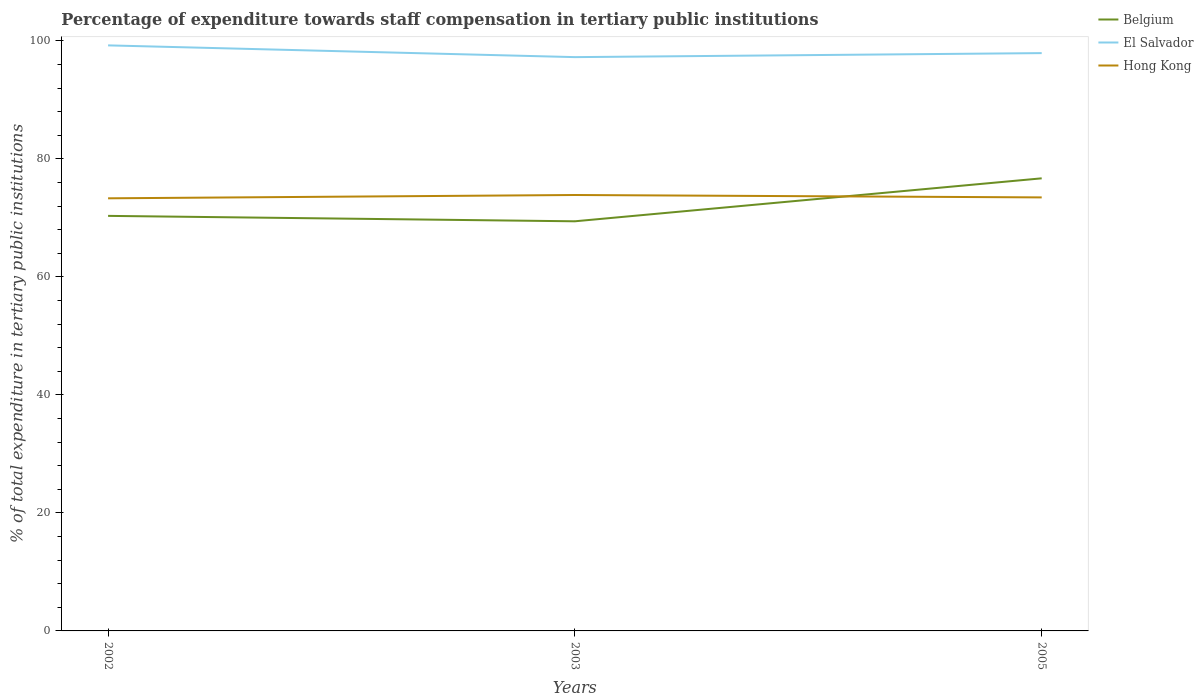Does the line corresponding to El Salvador intersect with the line corresponding to Belgium?
Offer a terse response. No. Is the number of lines equal to the number of legend labels?
Make the answer very short. Yes. Across all years, what is the maximum percentage of expenditure towards staff compensation in Hong Kong?
Offer a terse response. 73.32. What is the total percentage of expenditure towards staff compensation in Hong Kong in the graph?
Offer a very short reply. 0.41. What is the difference between the highest and the second highest percentage of expenditure towards staff compensation in Belgium?
Offer a terse response. 7.28. Is the percentage of expenditure towards staff compensation in Hong Kong strictly greater than the percentage of expenditure towards staff compensation in El Salvador over the years?
Provide a succinct answer. Yes. How many lines are there?
Ensure brevity in your answer.  3. How many years are there in the graph?
Offer a very short reply. 3. What is the difference between two consecutive major ticks on the Y-axis?
Provide a succinct answer. 20. Are the values on the major ticks of Y-axis written in scientific E-notation?
Offer a terse response. No. Where does the legend appear in the graph?
Your answer should be compact. Top right. How are the legend labels stacked?
Offer a terse response. Vertical. What is the title of the graph?
Give a very brief answer. Percentage of expenditure towards staff compensation in tertiary public institutions. Does "Paraguay" appear as one of the legend labels in the graph?
Offer a very short reply. No. What is the label or title of the Y-axis?
Provide a succinct answer. % of total expenditure in tertiary public institutions. What is the % of total expenditure in tertiary public institutions in Belgium in 2002?
Provide a succinct answer. 70.34. What is the % of total expenditure in tertiary public institutions in El Salvador in 2002?
Ensure brevity in your answer.  99.24. What is the % of total expenditure in tertiary public institutions of Hong Kong in 2002?
Offer a terse response. 73.32. What is the % of total expenditure in tertiary public institutions in Belgium in 2003?
Make the answer very short. 69.43. What is the % of total expenditure in tertiary public institutions in El Salvador in 2003?
Give a very brief answer. 97.25. What is the % of total expenditure in tertiary public institutions in Hong Kong in 2003?
Your response must be concise. 73.88. What is the % of total expenditure in tertiary public institutions of Belgium in 2005?
Make the answer very short. 76.71. What is the % of total expenditure in tertiary public institutions in El Salvador in 2005?
Ensure brevity in your answer.  97.93. What is the % of total expenditure in tertiary public institutions of Hong Kong in 2005?
Your answer should be very brief. 73.47. Across all years, what is the maximum % of total expenditure in tertiary public institutions of Belgium?
Your answer should be compact. 76.71. Across all years, what is the maximum % of total expenditure in tertiary public institutions in El Salvador?
Your answer should be compact. 99.24. Across all years, what is the maximum % of total expenditure in tertiary public institutions of Hong Kong?
Keep it short and to the point. 73.88. Across all years, what is the minimum % of total expenditure in tertiary public institutions in Belgium?
Your answer should be very brief. 69.43. Across all years, what is the minimum % of total expenditure in tertiary public institutions of El Salvador?
Offer a very short reply. 97.25. Across all years, what is the minimum % of total expenditure in tertiary public institutions in Hong Kong?
Give a very brief answer. 73.32. What is the total % of total expenditure in tertiary public institutions in Belgium in the graph?
Provide a succinct answer. 216.47. What is the total % of total expenditure in tertiary public institutions in El Salvador in the graph?
Offer a terse response. 294.42. What is the total % of total expenditure in tertiary public institutions in Hong Kong in the graph?
Offer a terse response. 220.67. What is the difference between the % of total expenditure in tertiary public institutions in Belgium in 2002 and that in 2003?
Your response must be concise. 0.92. What is the difference between the % of total expenditure in tertiary public institutions in El Salvador in 2002 and that in 2003?
Your answer should be compact. 1.99. What is the difference between the % of total expenditure in tertiary public institutions in Hong Kong in 2002 and that in 2003?
Offer a terse response. -0.56. What is the difference between the % of total expenditure in tertiary public institutions of Belgium in 2002 and that in 2005?
Offer a very short reply. -6.36. What is the difference between the % of total expenditure in tertiary public institutions of El Salvador in 2002 and that in 2005?
Your response must be concise. 1.31. What is the difference between the % of total expenditure in tertiary public institutions of Hong Kong in 2002 and that in 2005?
Ensure brevity in your answer.  -0.15. What is the difference between the % of total expenditure in tertiary public institutions of Belgium in 2003 and that in 2005?
Your answer should be compact. -7.28. What is the difference between the % of total expenditure in tertiary public institutions in El Salvador in 2003 and that in 2005?
Your answer should be compact. -0.68. What is the difference between the % of total expenditure in tertiary public institutions of Hong Kong in 2003 and that in 2005?
Your answer should be very brief. 0.41. What is the difference between the % of total expenditure in tertiary public institutions in Belgium in 2002 and the % of total expenditure in tertiary public institutions in El Salvador in 2003?
Offer a very short reply. -26.9. What is the difference between the % of total expenditure in tertiary public institutions of Belgium in 2002 and the % of total expenditure in tertiary public institutions of Hong Kong in 2003?
Your answer should be very brief. -3.54. What is the difference between the % of total expenditure in tertiary public institutions of El Salvador in 2002 and the % of total expenditure in tertiary public institutions of Hong Kong in 2003?
Your answer should be compact. 25.36. What is the difference between the % of total expenditure in tertiary public institutions in Belgium in 2002 and the % of total expenditure in tertiary public institutions in El Salvador in 2005?
Your answer should be compact. -27.59. What is the difference between the % of total expenditure in tertiary public institutions of Belgium in 2002 and the % of total expenditure in tertiary public institutions of Hong Kong in 2005?
Ensure brevity in your answer.  -3.13. What is the difference between the % of total expenditure in tertiary public institutions of El Salvador in 2002 and the % of total expenditure in tertiary public institutions of Hong Kong in 2005?
Give a very brief answer. 25.77. What is the difference between the % of total expenditure in tertiary public institutions of Belgium in 2003 and the % of total expenditure in tertiary public institutions of El Salvador in 2005?
Your answer should be very brief. -28.5. What is the difference between the % of total expenditure in tertiary public institutions of Belgium in 2003 and the % of total expenditure in tertiary public institutions of Hong Kong in 2005?
Provide a succinct answer. -4.05. What is the difference between the % of total expenditure in tertiary public institutions of El Salvador in 2003 and the % of total expenditure in tertiary public institutions of Hong Kong in 2005?
Ensure brevity in your answer.  23.78. What is the average % of total expenditure in tertiary public institutions in Belgium per year?
Provide a succinct answer. 72.16. What is the average % of total expenditure in tertiary public institutions in El Salvador per year?
Your answer should be very brief. 98.14. What is the average % of total expenditure in tertiary public institutions in Hong Kong per year?
Give a very brief answer. 73.56. In the year 2002, what is the difference between the % of total expenditure in tertiary public institutions in Belgium and % of total expenditure in tertiary public institutions in El Salvador?
Keep it short and to the point. -28.9. In the year 2002, what is the difference between the % of total expenditure in tertiary public institutions of Belgium and % of total expenditure in tertiary public institutions of Hong Kong?
Make the answer very short. -2.98. In the year 2002, what is the difference between the % of total expenditure in tertiary public institutions in El Salvador and % of total expenditure in tertiary public institutions in Hong Kong?
Offer a terse response. 25.92. In the year 2003, what is the difference between the % of total expenditure in tertiary public institutions in Belgium and % of total expenditure in tertiary public institutions in El Salvador?
Your answer should be very brief. -27.82. In the year 2003, what is the difference between the % of total expenditure in tertiary public institutions of Belgium and % of total expenditure in tertiary public institutions of Hong Kong?
Your answer should be very brief. -4.46. In the year 2003, what is the difference between the % of total expenditure in tertiary public institutions in El Salvador and % of total expenditure in tertiary public institutions in Hong Kong?
Your answer should be compact. 23.37. In the year 2005, what is the difference between the % of total expenditure in tertiary public institutions of Belgium and % of total expenditure in tertiary public institutions of El Salvador?
Your response must be concise. -21.22. In the year 2005, what is the difference between the % of total expenditure in tertiary public institutions of Belgium and % of total expenditure in tertiary public institutions of Hong Kong?
Keep it short and to the point. 3.23. In the year 2005, what is the difference between the % of total expenditure in tertiary public institutions in El Salvador and % of total expenditure in tertiary public institutions in Hong Kong?
Provide a succinct answer. 24.46. What is the ratio of the % of total expenditure in tertiary public institutions of Belgium in 2002 to that in 2003?
Your answer should be very brief. 1.01. What is the ratio of the % of total expenditure in tertiary public institutions of El Salvador in 2002 to that in 2003?
Your answer should be very brief. 1.02. What is the ratio of the % of total expenditure in tertiary public institutions of Hong Kong in 2002 to that in 2003?
Provide a short and direct response. 0.99. What is the ratio of the % of total expenditure in tertiary public institutions in Belgium in 2002 to that in 2005?
Give a very brief answer. 0.92. What is the ratio of the % of total expenditure in tertiary public institutions in El Salvador in 2002 to that in 2005?
Keep it short and to the point. 1.01. What is the ratio of the % of total expenditure in tertiary public institutions of Belgium in 2003 to that in 2005?
Keep it short and to the point. 0.91. What is the ratio of the % of total expenditure in tertiary public institutions in Hong Kong in 2003 to that in 2005?
Provide a short and direct response. 1.01. What is the difference between the highest and the second highest % of total expenditure in tertiary public institutions in Belgium?
Offer a very short reply. 6.36. What is the difference between the highest and the second highest % of total expenditure in tertiary public institutions of El Salvador?
Keep it short and to the point. 1.31. What is the difference between the highest and the second highest % of total expenditure in tertiary public institutions of Hong Kong?
Keep it short and to the point. 0.41. What is the difference between the highest and the lowest % of total expenditure in tertiary public institutions of Belgium?
Keep it short and to the point. 7.28. What is the difference between the highest and the lowest % of total expenditure in tertiary public institutions of El Salvador?
Your answer should be compact. 1.99. What is the difference between the highest and the lowest % of total expenditure in tertiary public institutions in Hong Kong?
Provide a short and direct response. 0.56. 